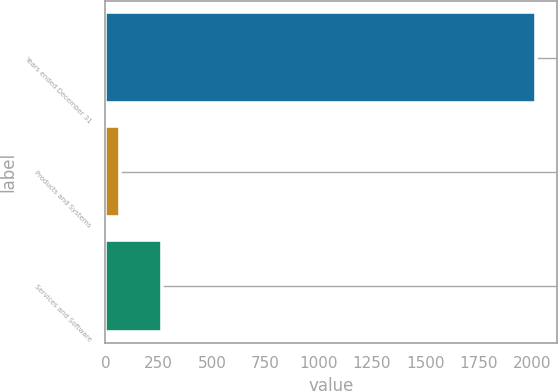Convert chart. <chart><loc_0><loc_0><loc_500><loc_500><bar_chart><fcel>Years ended December 31<fcel>Products and Systems<fcel>Services and Software<nl><fcel>2017<fcel>69<fcel>263.8<nl></chart> 